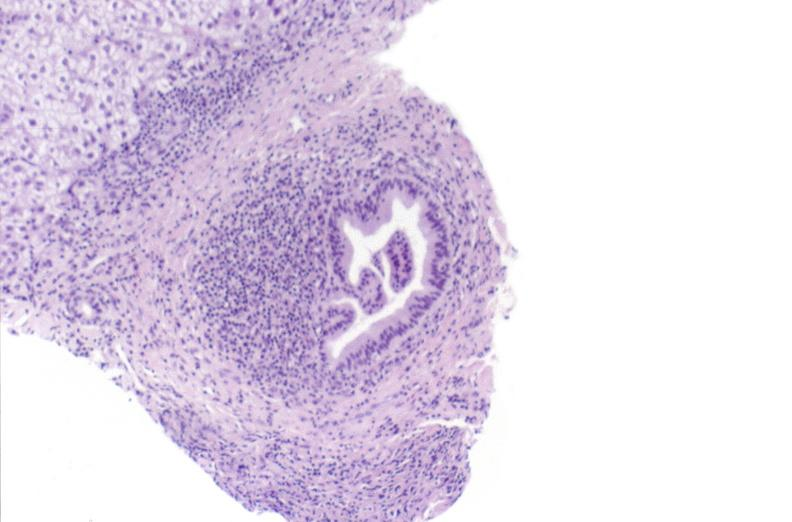s liver present?
Answer the question using a single word or phrase. Yes 